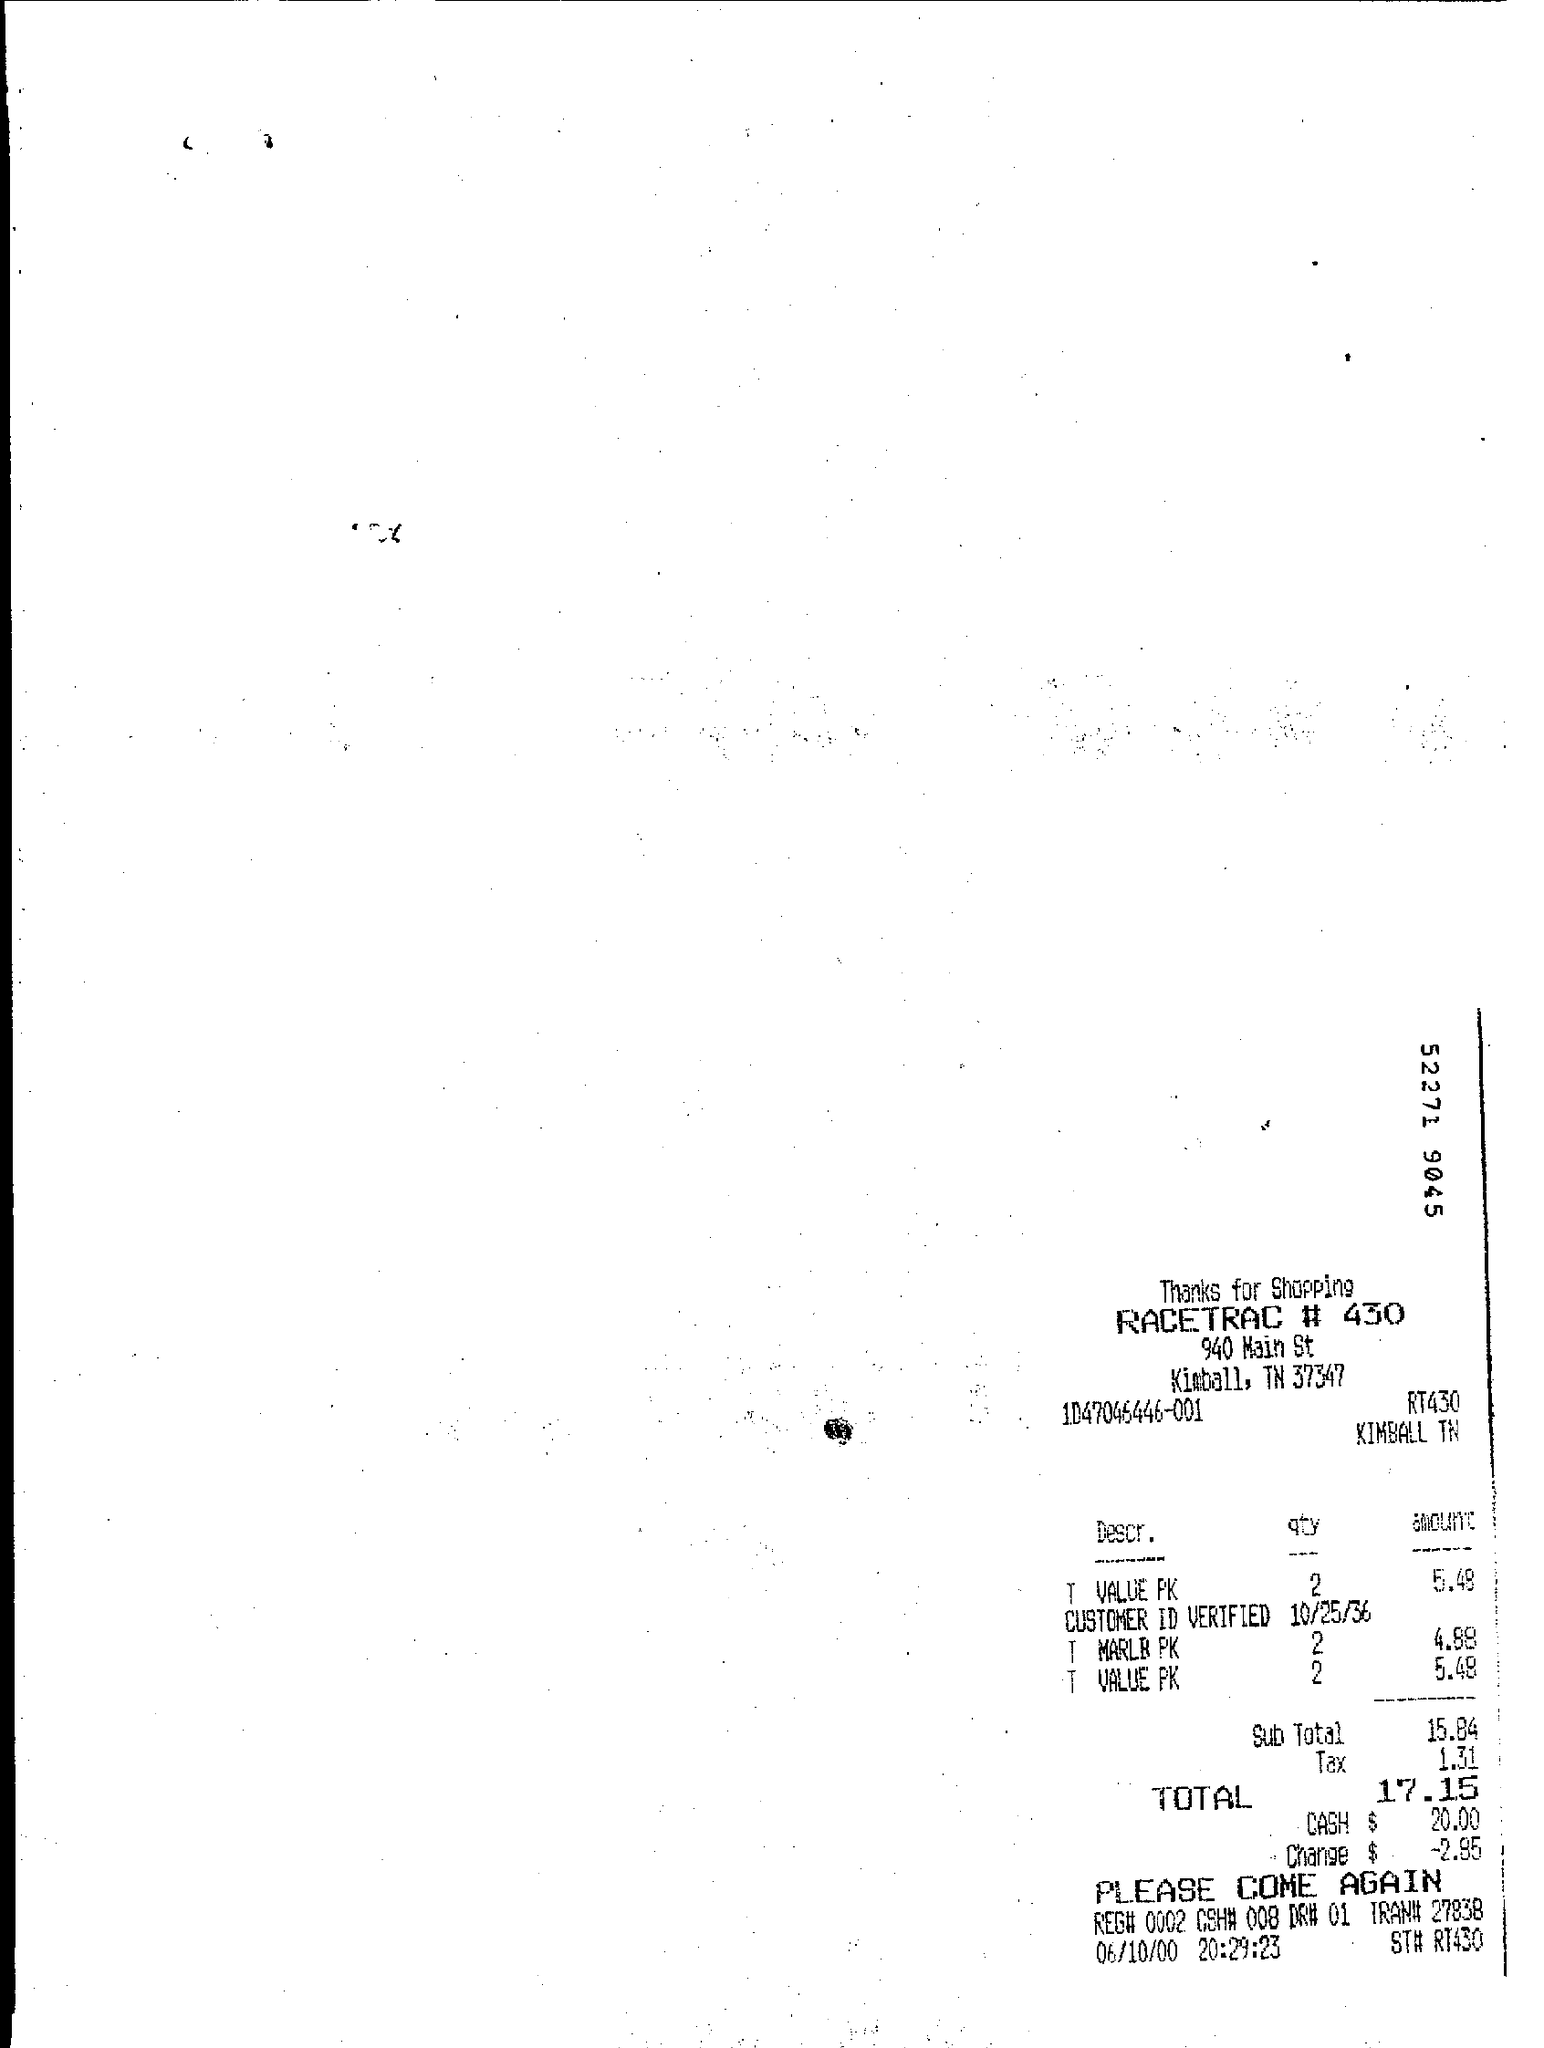Give some essential details in this illustration. Approximately two T VALUE PKs were purchased. What is the tax in dollars given 1.31...? The total amount spent is $17.15. 